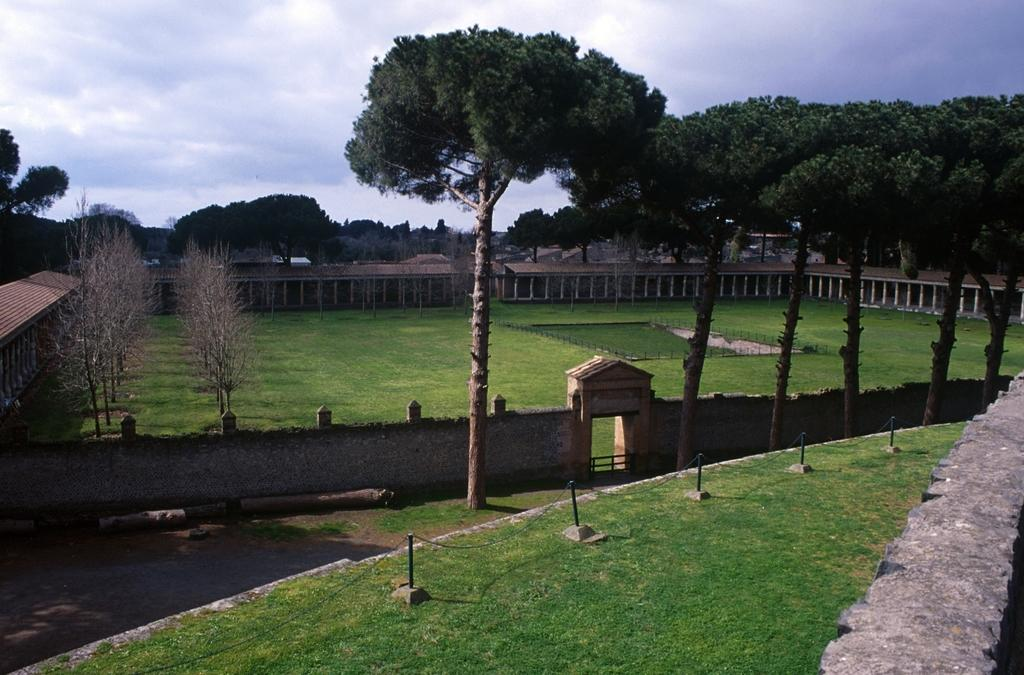What type of vegetation can be seen in the image? There is grass in the image. What architectural features are present in the image? There are pillars, fencing, and buildings in the image. What type of natural structures can be seen in the image? There are trees in the image. What is the background of the image composed of? The background of the image includes a wall, the sky, clouds, and possibly some of the buildings. What invention is being discussed by the committee in the image? There is no committee or invention present in the image. What is the fifth element in the image? The facts provided do not indicate a specific number of elements in the image, so it is not possible to determine a "fifth" element. 